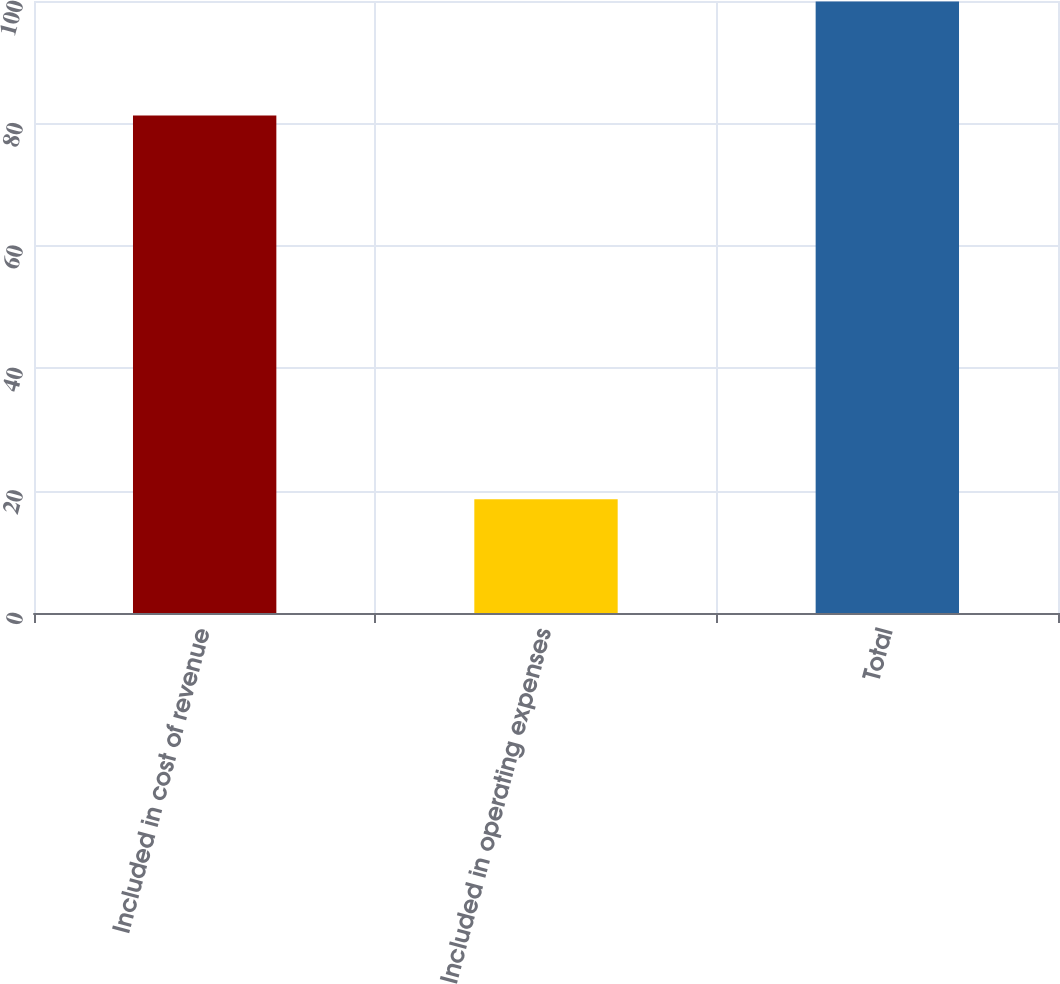Convert chart to OTSL. <chart><loc_0><loc_0><loc_500><loc_500><bar_chart><fcel>Included in cost of revenue<fcel>Included in operating expenses<fcel>Total<nl><fcel>81.3<fcel>18.6<fcel>99.9<nl></chart> 